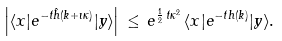<formula> <loc_0><loc_0><loc_500><loc_500>\left | \langle x | e ^ { - t \hat { h } ( k + \imath \kappa ) } | y \rangle \right | \, \leq \, e ^ { \frac { 1 } { 2 } \, t \kappa ^ { 2 } } \, \langle x | e ^ { - t h ( k ) } | y \rangle .</formula> 